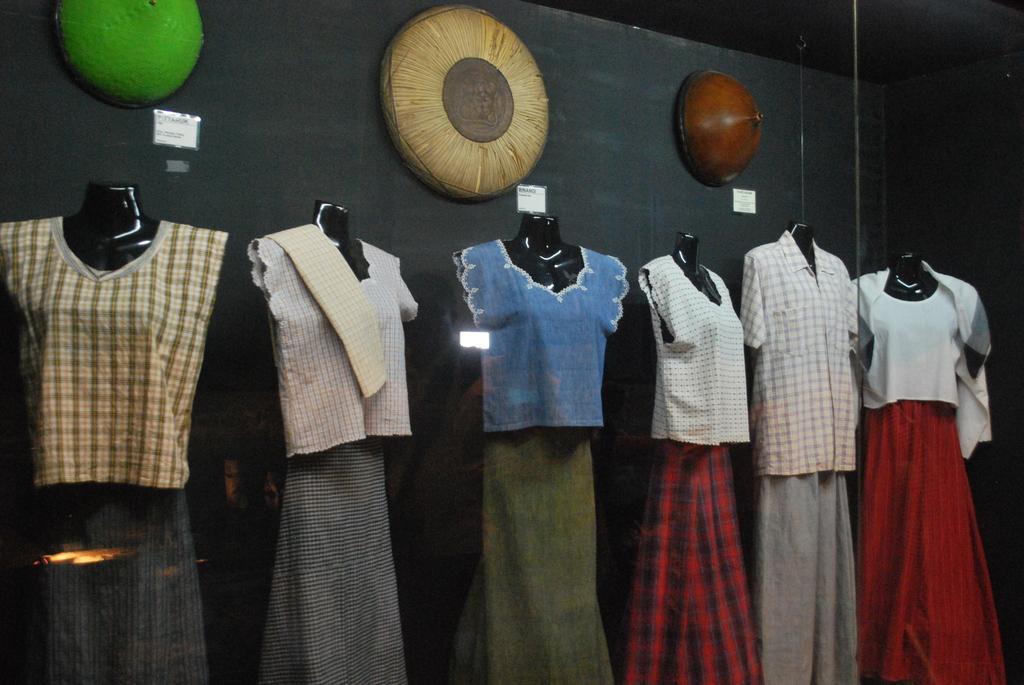Describe this image in one or two sentences. In the foreground of the picture there is a glass, inside the glass there are mannequins with different costumes. In the background there are some objects attached to the wall, the wall is painted black. 